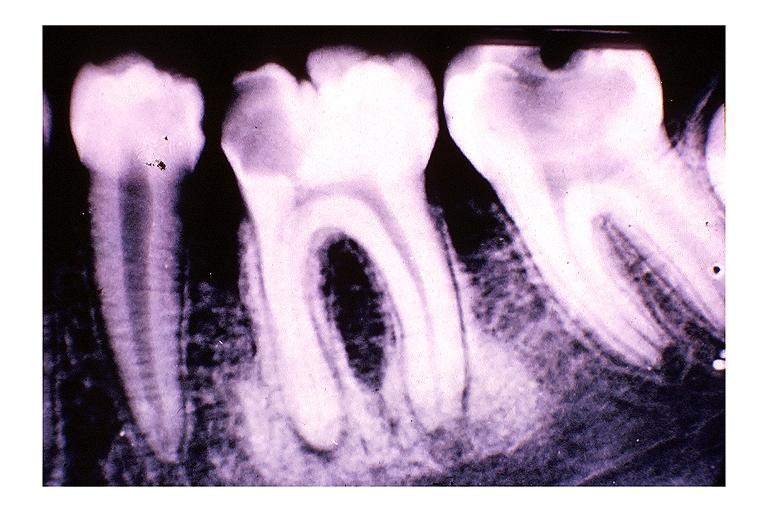s supernumerary digits present?
Answer the question using a single word or phrase. No 